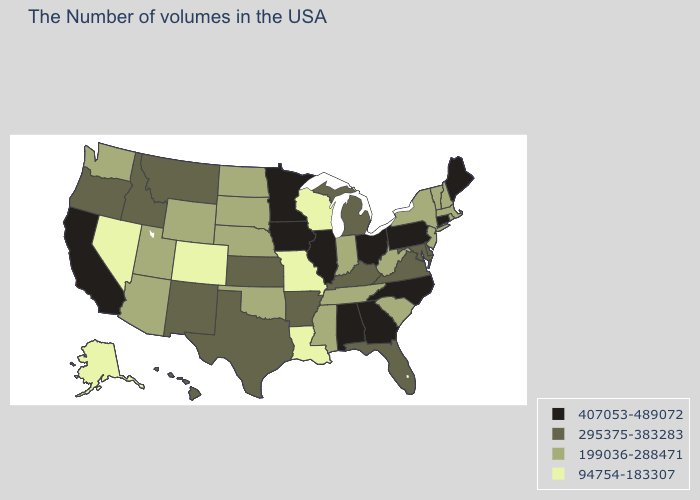Among the states that border Arizona , which have the highest value?
Keep it brief. California. What is the lowest value in states that border Massachusetts?
Answer briefly. 199036-288471. What is the lowest value in the USA?
Concise answer only. 94754-183307. What is the value of Arkansas?
Write a very short answer. 295375-383283. What is the value of Maryland?
Quick response, please. 295375-383283. What is the lowest value in the USA?
Keep it brief. 94754-183307. What is the highest value in the MidWest ?
Keep it brief. 407053-489072. Name the states that have a value in the range 407053-489072?
Quick response, please. Maine, Connecticut, Pennsylvania, North Carolina, Ohio, Georgia, Alabama, Illinois, Minnesota, Iowa, California. What is the highest value in the USA?
Keep it brief. 407053-489072. What is the value of Nevada?
Keep it brief. 94754-183307. Among the states that border West Virginia , does Virginia have the highest value?
Answer briefly. No. What is the lowest value in the West?
Concise answer only. 94754-183307. What is the highest value in states that border Nebraska?
Be succinct. 407053-489072. Does Vermont have the lowest value in the Northeast?
Quick response, please. Yes. 